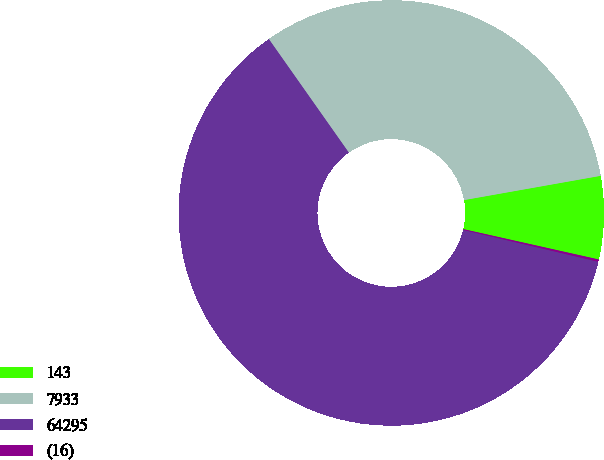<chart> <loc_0><loc_0><loc_500><loc_500><pie_chart><fcel>143<fcel>7933<fcel>64295<fcel>(16)<nl><fcel>6.31%<fcel>31.97%<fcel>61.55%<fcel>0.17%<nl></chart> 